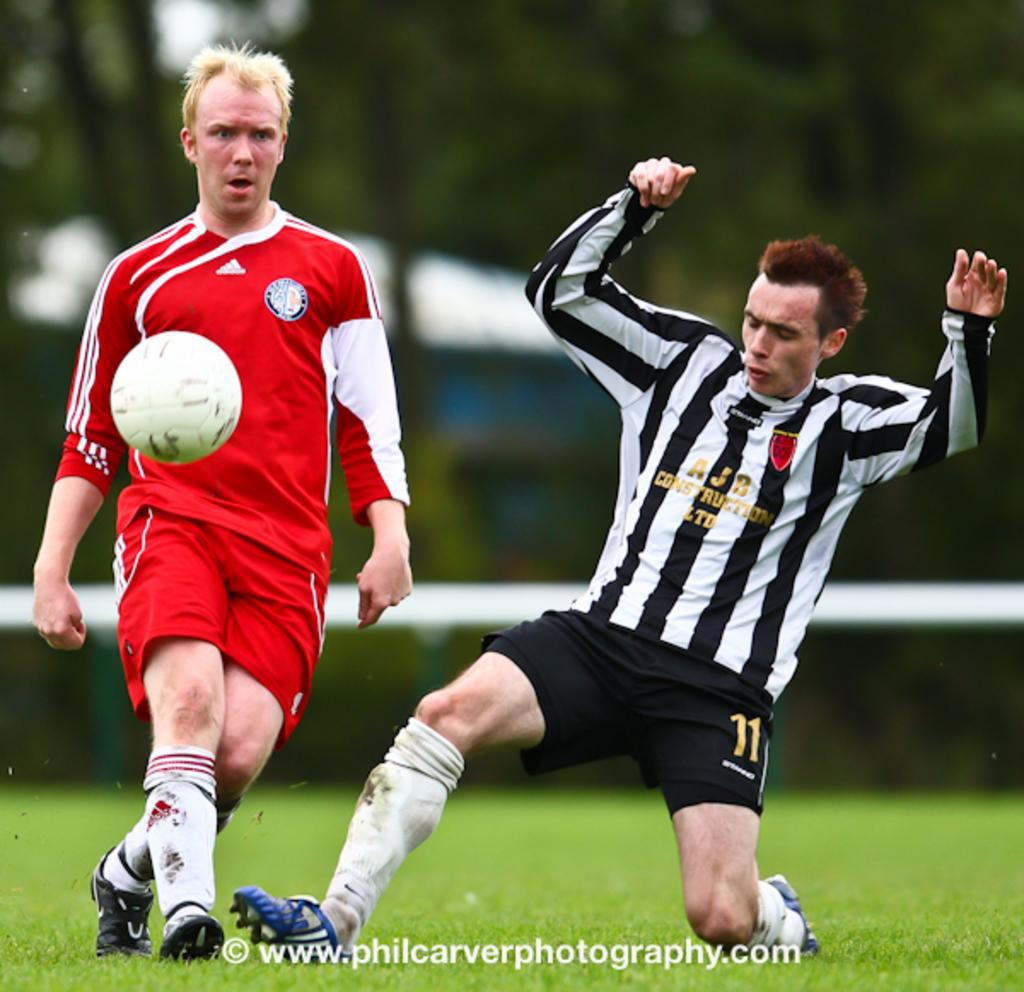<image>
Present a compact description of the photo's key features. The number 11 soccer player is going for a tackle on the red shirt player. 